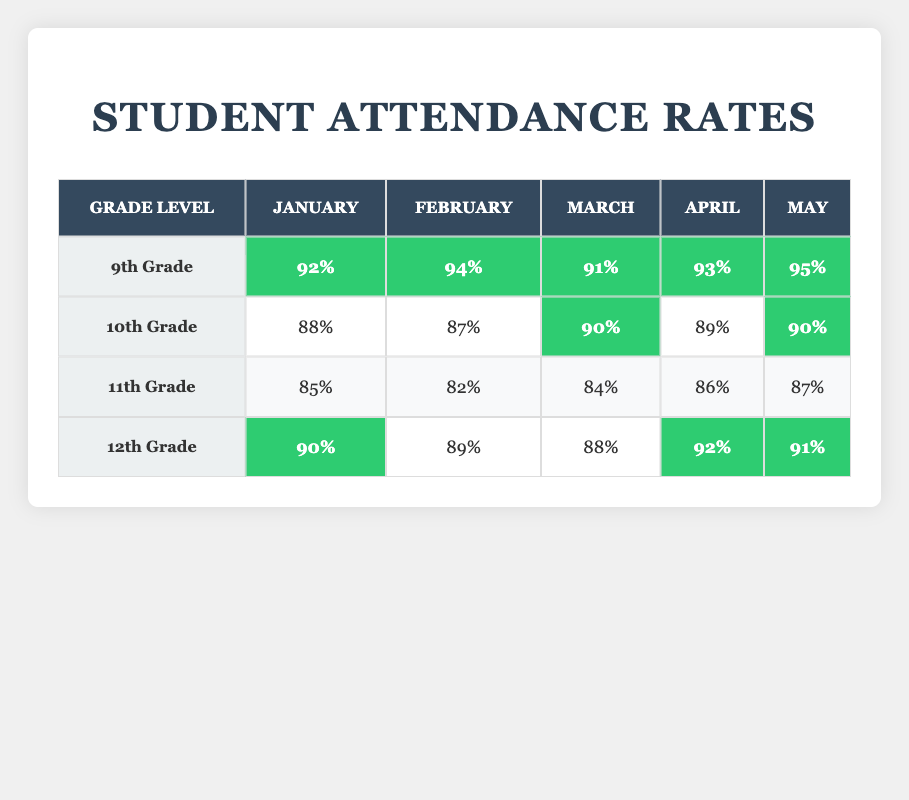What was the attendance rate for 10th Grade in March? According to the table, the attendance rate for 10th Grade in March is listed under the "March" column and the "10th Grade" row. It shows a value of 90%.
Answer: 90% Which month had the highest attendance rate for 9th Grade? By examining the 9th Grade row across all months, the rates are 92%, 94%, 91%, 93%, and 95%. The highest value among these is 95% in May.
Answer: May What is the average attendance rate for 12th Grade over the five months? To calculate the average, we sum the attendance rates for 12th Grade: (90 + 89 + 88 + 92 + 91) = 450. Then, we divide by the number of months, which is 5: 450 / 5 = 90.
Answer: 90 Did 11th Grade have a higher attendance rate than 10th Grade in April? In April, the attendance rates are 86% for 11th Grade and 89% for 10th Grade. Since 89% is greater than 86%, we conclude that 11th Grade did not have a higher rate.
Answer: No Which grade had the most consistent attendance rates across the months? To determine consistency, we review the attendance rates for each grade: 9th Grade (92, 94, 91, 93, 95), 10th Grade (88, 87, 90, 89, 90), 11th Grade (85, 82, 84, 86, 87), and 12th Grade (90, 89, 88, 92, 91). The smallest variation is in 12th Grade, with attendance rates closely clustered around 90%, indicating higher consistency.
Answer: 12th Grade 